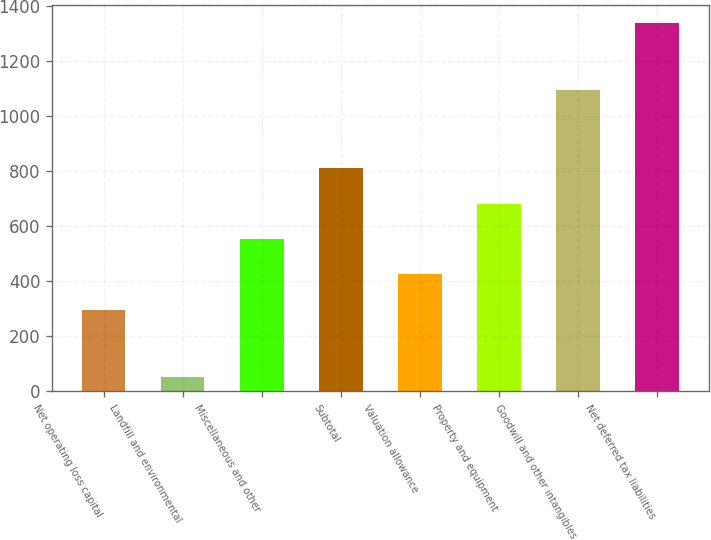Convert chart. <chart><loc_0><loc_0><loc_500><loc_500><bar_chart><fcel>Net operating loss capital<fcel>Landfill and environmental<fcel>Miscellaneous and other<fcel>Subtotal<fcel>Valuation allowance<fcel>Property and equipment<fcel>Goodwill and other intangibles<fcel>Net deferred tax liabilities<nl><fcel>297<fcel>53<fcel>554<fcel>811<fcel>425.5<fcel>682.5<fcel>1095<fcel>1338<nl></chart> 